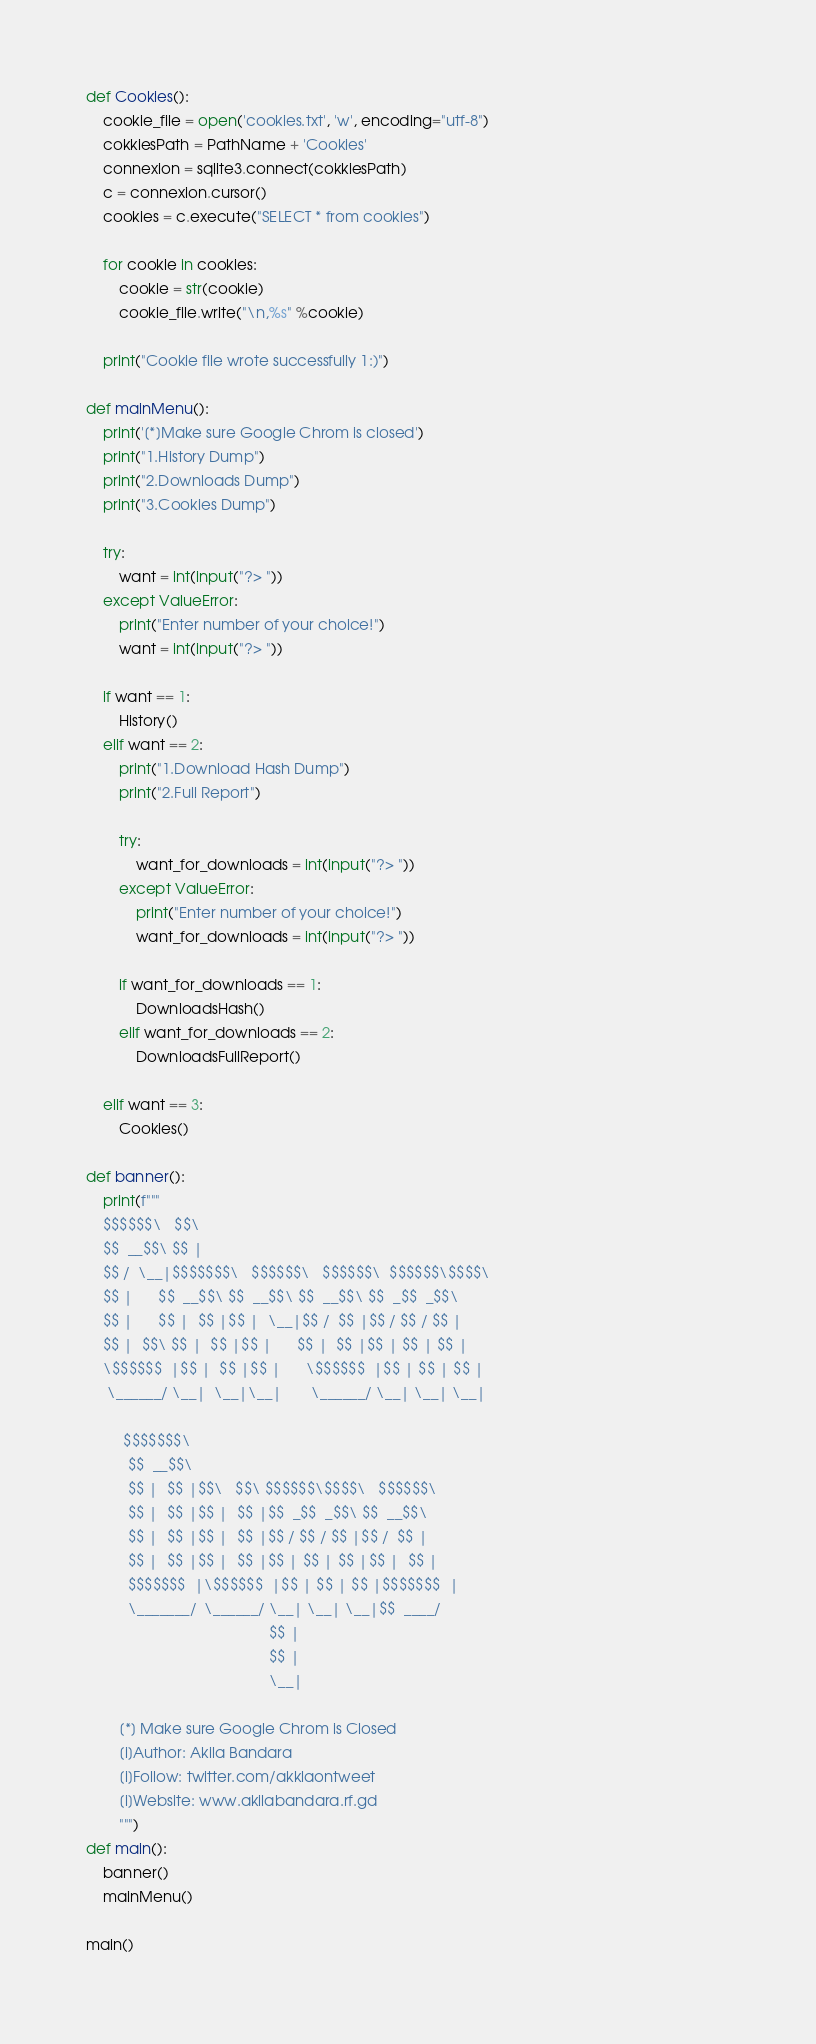Convert code to text. <code><loc_0><loc_0><loc_500><loc_500><_Python_>
def Cookies():
	cookie_file = open('cookies.txt', 'w', encoding="utf-8")
	cokkiesPath = PathName + 'Cookies'
	connexion = sqlite3.connect(cokkiesPath)
	c = connexion.cursor()
	cookies = c.execute("SELECT * from cookies")

	for cookie in cookies:
		cookie = str(cookie)
		cookie_file.write("\n,%s" %cookie)

	print("Cookie file wrote successfully 1:)")

def mainMenu():
	print('[*]Make sure Google Chrom is closed')
	print("1.History Dump")
	print("2.Downloads Dump")
	print("3.Cookies Dump")
	
	try:
		want = int(input("?> "))
	except ValueError:
		print("Enter number of your choice!")
		want = int(input("?> "))

	if want == 1:
		History()
	elif want == 2:
		print("1.Download Hash Dump")
		print("2.Full Report")

		try:
			want_for_downloads = int(input("?> "))
		except ValueError:
			print("Enter number of your choice!")
			want_for_downloads = int(input("?> "))

		if want_for_downloads == 1:
			DownloadsHash()
		elif want_for_downloads == 2:
			DownloadsFullReport()

	elif want == 3:
		Cookies()

def banner():
	print(f"""		                                                             
	$$$$$$\   $$\                                         
	$$  __$$\ $$ |                                        
	$$ /  \__|$$$$$$$\   $$$$$$\   $$$$$$\  $$$$$$\$$$$\  
	$$ |      $$  __$$\ $$  __$$\ $$  __$$\ $$  _$$  _$$\ 
	$$ |      $$ |  $$ |$$ |  \__|$$ /  $$ |$$ / $$ / $$ |
	$$ |  $$\ $$ |  $$ |$$ |      $$ |  $$ |$$ | $$ | $$ |
	\$$$$$$  |$$ |  $$ |$$ |      \$$$$$$  |$$ | $$ | $$ |
	 \______/ \__|  \__|\__|       \______/ \__| \__| \__|
                                                                                                                                                           
	     $$$$$$$\                                        
	      $$  __$$\                                       
	      $$ |  $$ |$$\   $$\ $$$$$$\$$$$\   $$$$$$\      
	      $$ |  $$ |$$ |  $$ |$$  _$$  _$$\ $$  __$$\     
	      $$ |  $$ |$$ |  $$ |$$ / $$ / $$ |$$ /  $$ |    
	      $$ |  $$ |$$ |  $$ |$$ | $$ | $$ |$$ |  $$ |    
	      $$$$$$$  |\$$$$$$  |$$ | $$ | $$ |$$$$$$$  |    
	      \_______/  \______/ \__| \__| \__|$$  ____/     
	                                        $$ |          
	                                        $$ |          
	                                        \__|       

		[*] Make sure Google Chrom is Closed
		[i]Author: Akila Bandara
		[i]Follow: twitter.com/akklaontweet
		[i]Website: www.akilabandara.rf.gd 
		""")
def main():
	banner()
	mainMenu()

main()</code> 